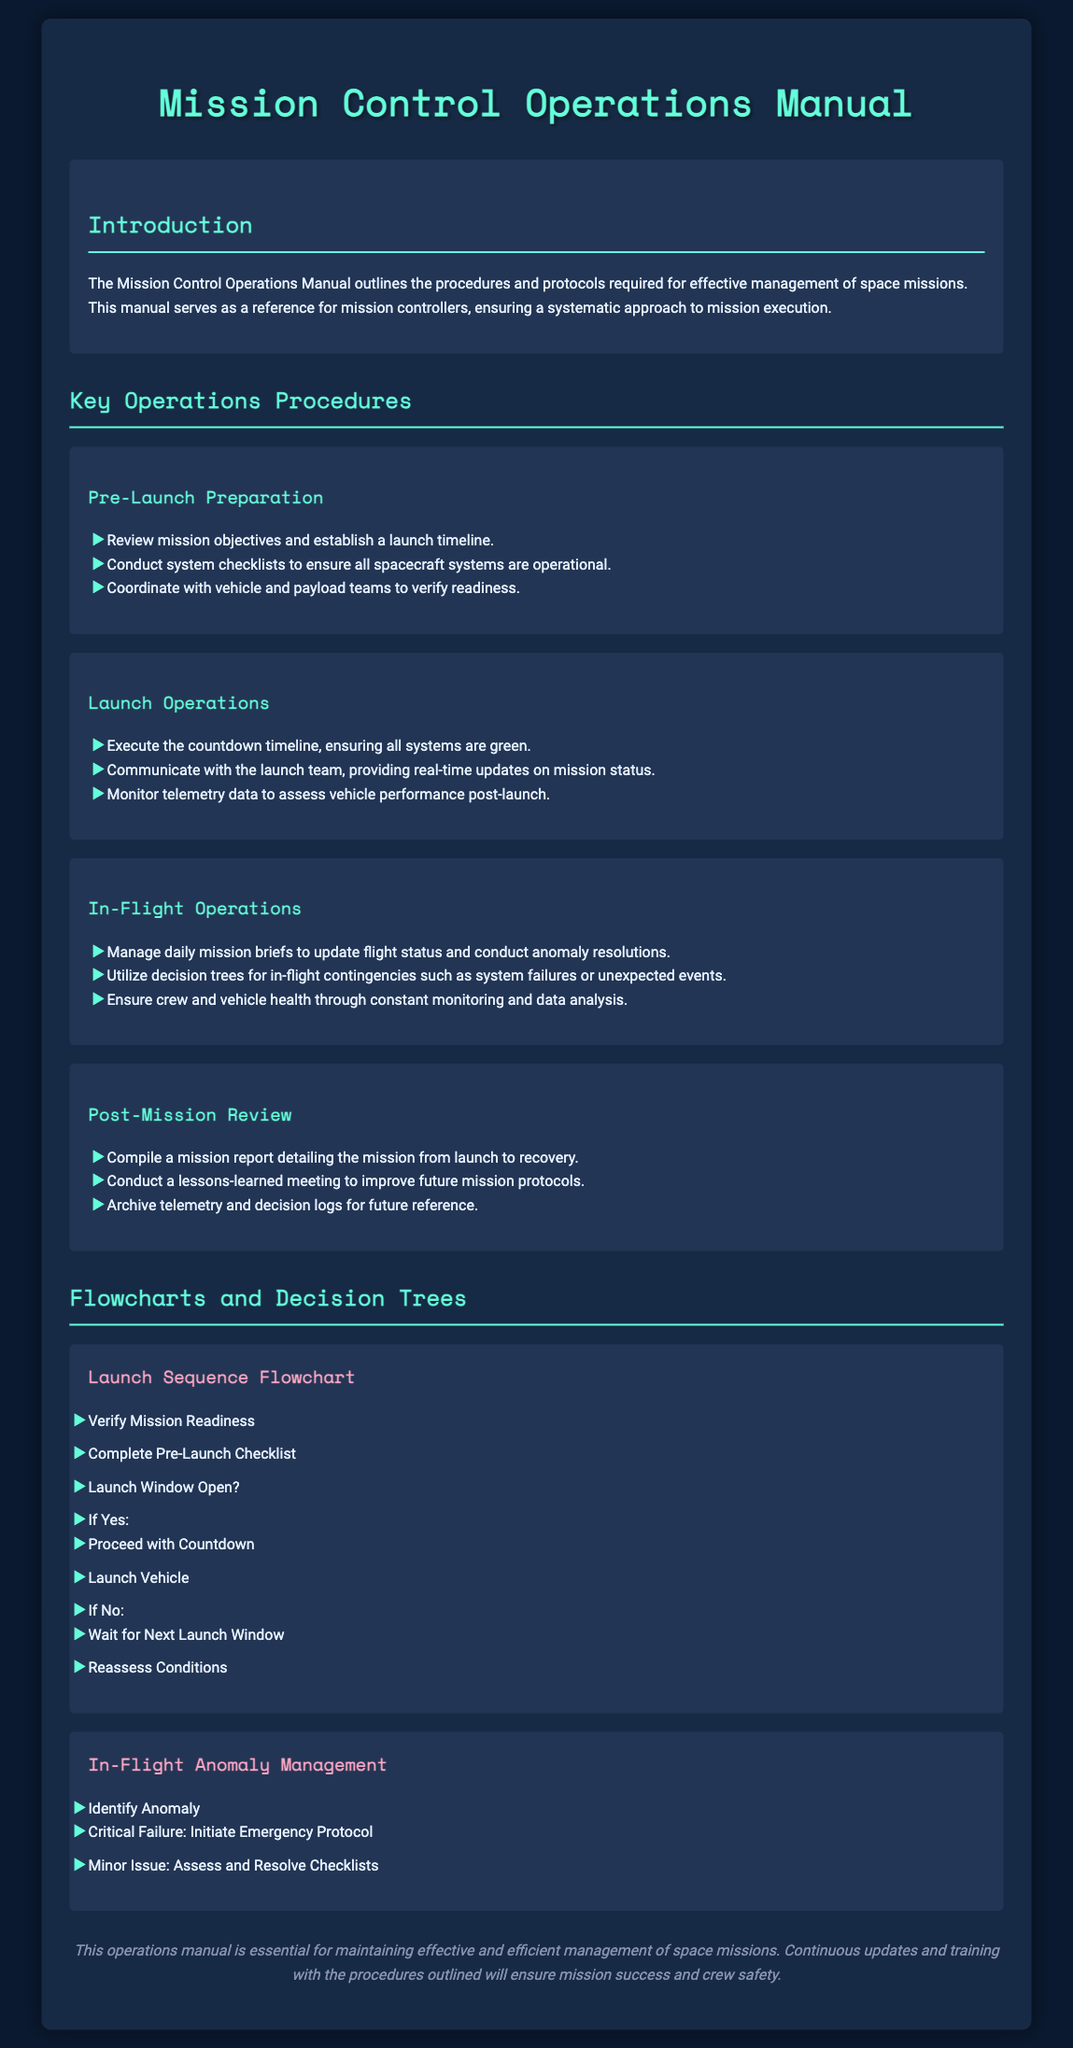what is the title of the manual? The title of the manual is presented prominently at the top of the document, which is "Mission Control Operations Manual."
Answer: Mission Control Operations Manual who is the target audience for the manual? The document specifies the target audience as "mission controllers," indicating they are the primary users of the manual.
Answer: mission controllers how many key operations procedures are mentioned? The document lists four key operations procedures under the "Key Operations Procedures" section.
Answer: four what is the first step in the Launch Sequence Flowchart? The first step in the Launch Sequence Flowchart is stated as "Verify Mission Readiness," which is the starting point of the flowchart.
Answer: Verify Mission Readiness what action should be taken during a Critical Failure in the In-Flight Anomaly Management? The document indicates that the appropriate action for a Critical Failure is to "Initiate Emergency Protocol."
Answer: Initiate Emergency Protocol what should be compiled after a mission? The document instructs to compile a "mission report" which details various aspects of the mission.
Answer: mission report what is the color of the text headings in the document? The text headings are highlighted in a specific color that is mentioned as "#64ffda," reflecting the design choice for visibility.
Answer: #64ffda how is the health of the crew and vehicle ensured during In-Flight Operations? The manual mentions that ensuring the crew and vehicle health involves "constant monitoring and data analysis."
Answer: constant monitoring and data analysis 